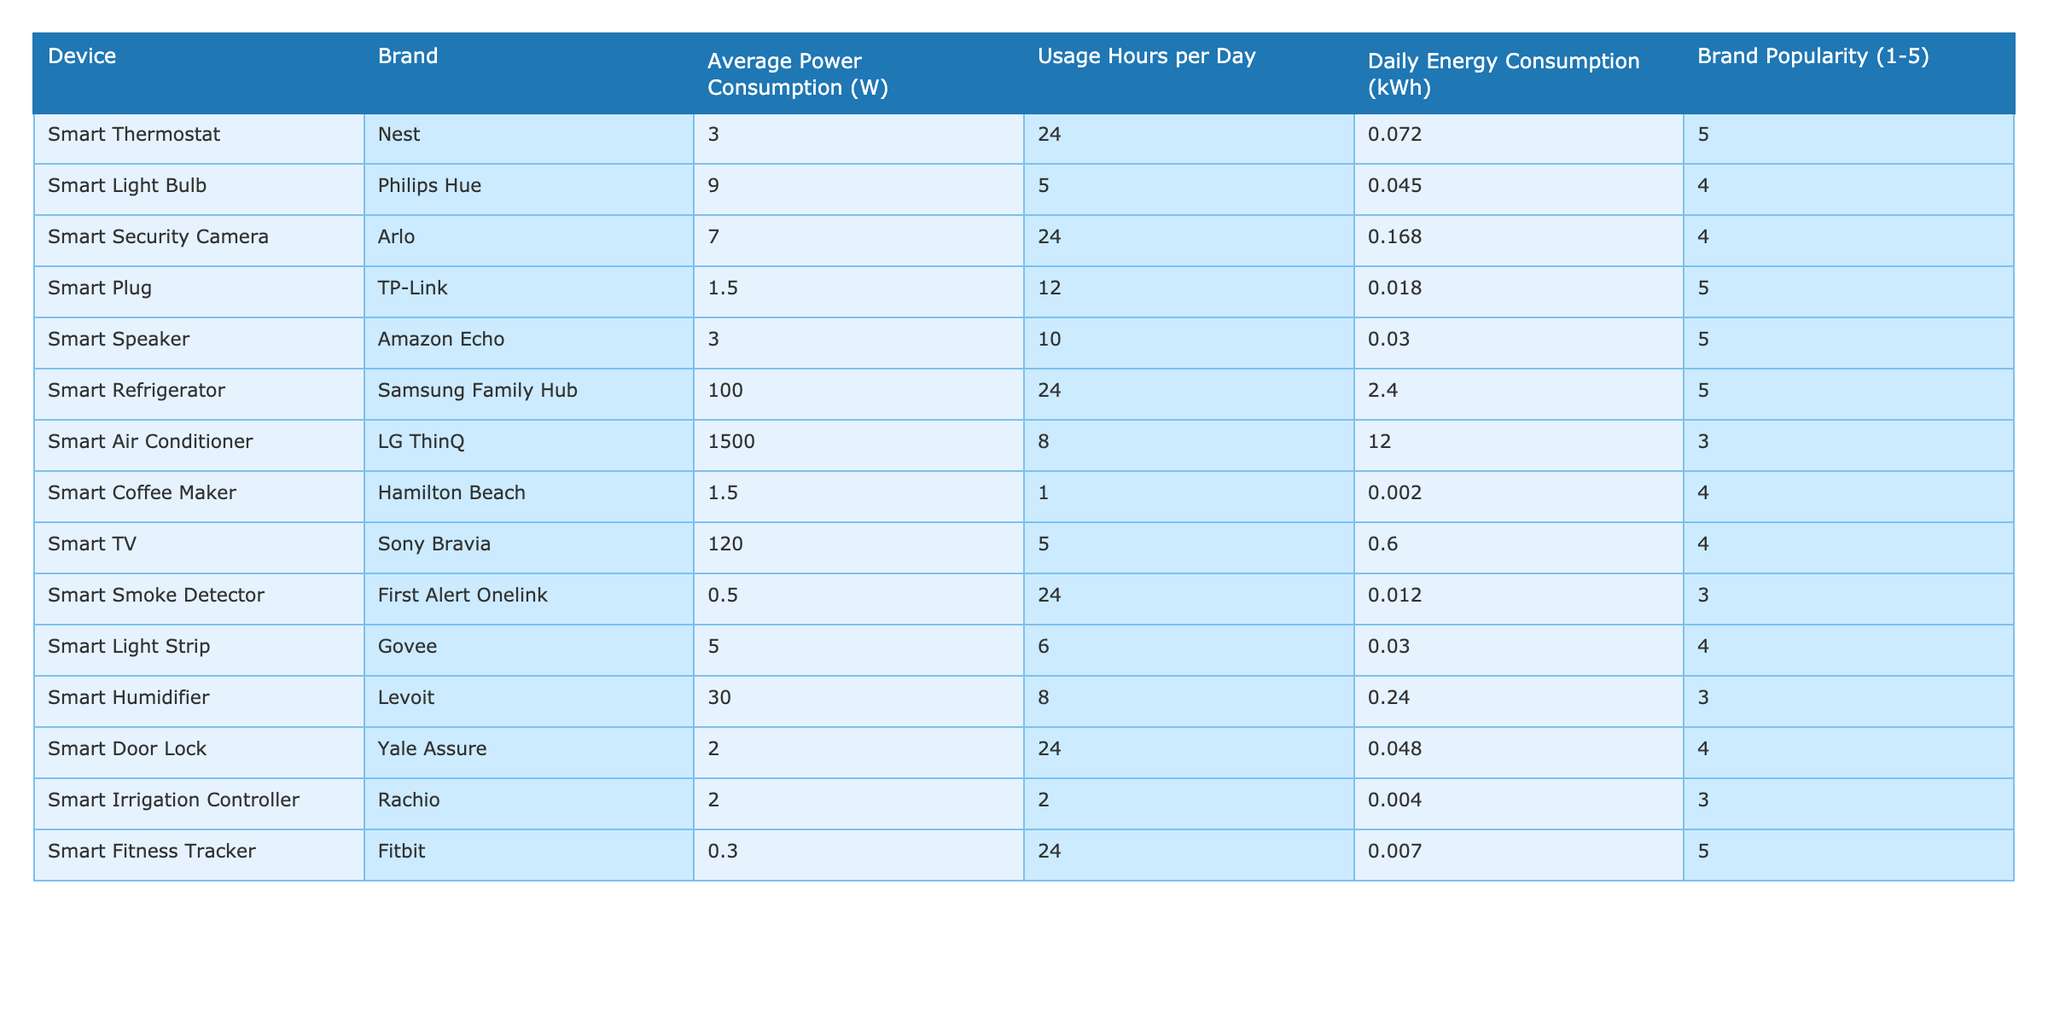What is the average power consumption of the smart light bulb? The table states that the average power consumption for the smart light bulb (Philips Hue) is 9 W.
Answer: 9 W Which device has the highest daily energy consumption? The smart refrigerator (Samsung Family Hub) has a daily energy consumption of 2.4 kWh, which is the highest among all devices.
Answer: Smart Refrigerator How much more daily energy does the smart air conditioner consume compared to the smart door lock? The smart air conditioner consumes 12 kWh and the smart door lock consumes 0.048 kWh. The difference is 12 - 0.048 = 11.952 kWh.
Answer: 11.952 kWh Is the average power consumption of the smart security camera higher than the smart light strip? The smart security camera consumes 7 W, while the smart light strip consumes 5 W; hence, the security camera does have a higher average power consumption.
Answer: Yes What is the total daily energy consumption of all devices? To find the total, sum up the daily energy consumption for all devices: 0.072 + 0.045 + 0.168 + 0.018 + 0.03 + 2.4 + 12 + 0.0015 + 0.6 + 0.012 + 0.03 + 0.24 + 0.048 + 0.004 + 0.0072 = 15.7367 kWh.
Answer: 15.7367 kWh How many devices have a brand popularity rating of 5? The table lists 5 devices with a brand popularity rating of 5: Smart Thermostat, Smart Plug, Smart Speaker, Smart Refrigerator, and Smart Fitness Tracker.
Answer: 5 What is the average daily energy consumption of all devices? The total daily energy consumption is 15.7367 kWh, and there are 15 devices; so, the average is 15.7367 / 15 ≈ 1.0485 kWh.
Answer: 1.0485 kWh Which device uses the least amount of energy daily? The smart coffee maker consumes the least at 0.0015 kWh daily.
Answer: Smart Coffee Maker If a user uses devices with the highest and lowest daily energy consumption together, what would be their combined daily energy consumption? The smart air conditioner (12 kWh) has the highest daily energy consumption and the smart coffee maker (0.0015 kWh) has the least. Their combined consumption is 12 + 0.0015 = 12.0015 kWh.
Answer: 12.0015 kWh Which brand has the most energy-efficient devices based on average power consumption? The brand with the less average power consumption among its devices is TP-Link, with an average of 1.5 W for its smart plug.
Answer: TP-Link 